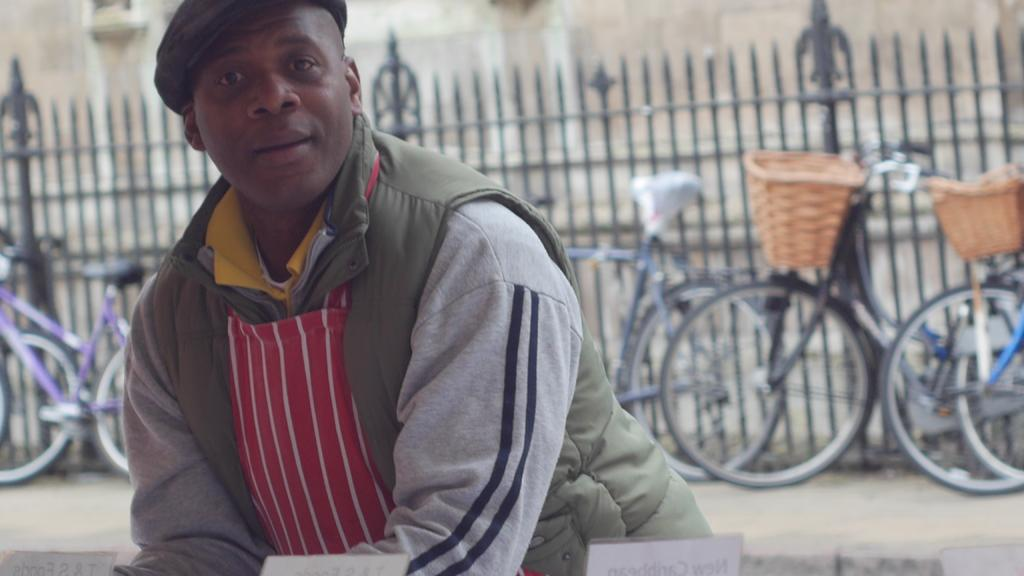What can be seen in the image? There is a person in the image. Can you describe the person's attire? The person is wearing a cap. What else is visible in the image? There are bicycles on the pavement behind the person, a fence in the background, and a building in the background. Where is the rabbit sitting on the sofa in the image? There is no rabbit or sofa present in the image. Can you describe the texture of the sand in the image? There is no sand present in the image. 